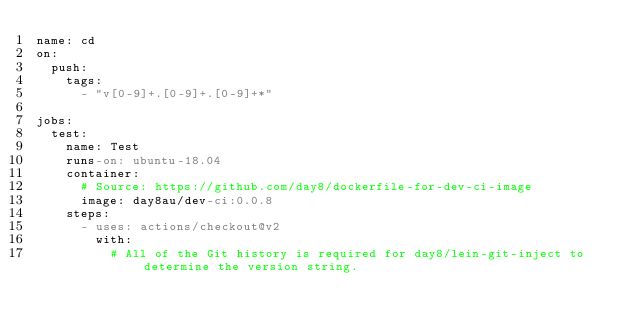<code> <loc_0><loc_0><loc_500><loc_500><_YAML_>name: cd
on:
  push:
    tags:
      - "v[0-9]+.[0-9]+.[0-9]+*"

jobs:
  test:
    name: Test
    runs-on: ubuntu-18.04
    container:
      # Source: https://github.com/day8/dockerfile-for-dev-ci-image
      image: day8au/dev-ci:0.0.8
    steps:
      - uses: actions/checkout@v2
        with:
          # All of the Git history is required for day8/lein-git-inject to determine the version string.</code> 